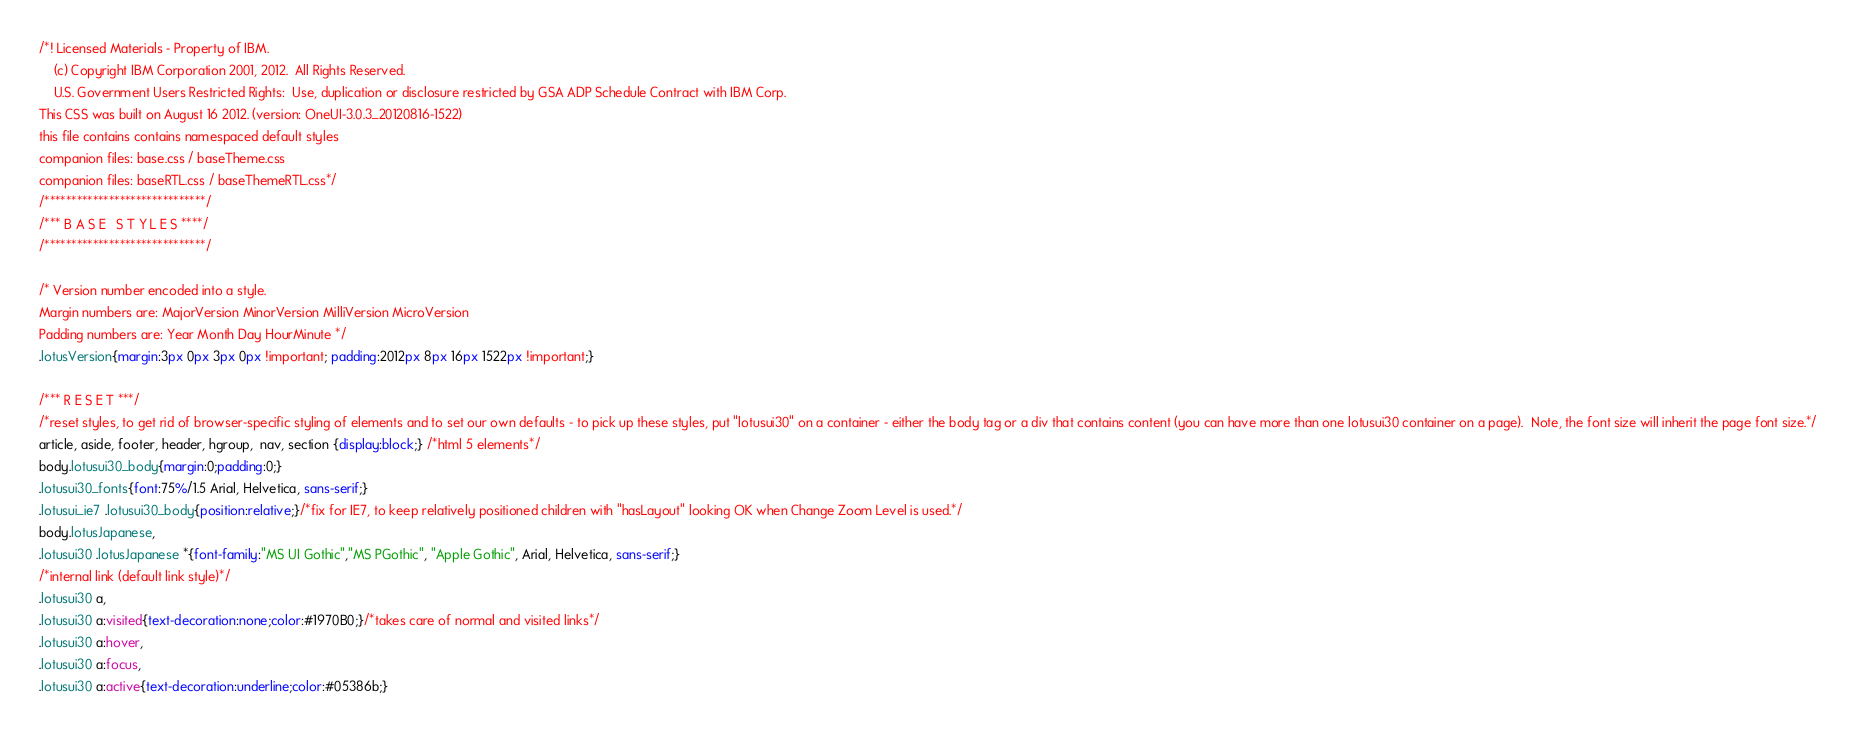Convert code to text. <code><loc_0><loc_0><loc_500><loc_500><_CSS_>/*! Licensed Materials - Property of IBM.
    (c) Copyright IBM Corporation 2001, 2012.  All Rights Reserved.
    U.S. Government Users Restricted Rights:  Use, duplication or disclosure restricted by GSA ADP Schedule Contract with IBM Corp.
This CSS was built on August 16 2012. (version: OneUI-3.0.3_20120816-1522)
this file contains contains namespaced default styles
companion files: base.css / baseTheme.css
companion files: baseRTL.css / baseThemeRTL.css*/
/******************************/
/*** B A S E   S T Y L E S ****/
/******************************/

/* Version number encoded into a style.
Margin numbers are: MajorVersion MinorVersion MilliVersion MicroVersion
Padding numbers are: Year Month Day HourMinute */
.lotusVersion{margin:3px 0px 3px 0px !important; padding:2012px 8px 16px 1522px !important;}

/*** R E S E T ***/
/*reset styles, to get rid of browser-specific styling of elements and to set our own defaults - to pick up these styles, put "lotusui30" on a container - either the body tag or a div that contains content (you can have more than one lotusui30 container on a page).  Note, the font size will inherit the page font size.*/
article, aside, footer, header, hgroup,  nav, section {display:block;} /*html 5 elements*/
body.lotusui30_body{margin:0;padding:0;}
.lotusui30_fonts{font:75%/1.5 Arial, Helvetica, sans-serif;}
.lotusui_ie7 .lotusui30_body{position:relative;}/*fix for IE7, to keep relatively positioned children with "hasLayout" looking OK when Change Zoom Level is used.*/
body.lotusJapanese, 
.lotusui30 .lotusJapanese *{font-family:"MS UI Gothic","MS PGothic", "Apple Gothic", Arial, Helvetica, sans-serif;}
/*internal link (default link style)*/
.lotusui30 a, 
.lotusui30 a:visited{text-decoration:none;color:#1970B0;}/*takes care of normal and visited links*/
.lotusui30 a:hover, 
.lotusui30 a:focus, 
.lotusui30 a:active{text-decoration:underline;color:#05386b;}
</code> 